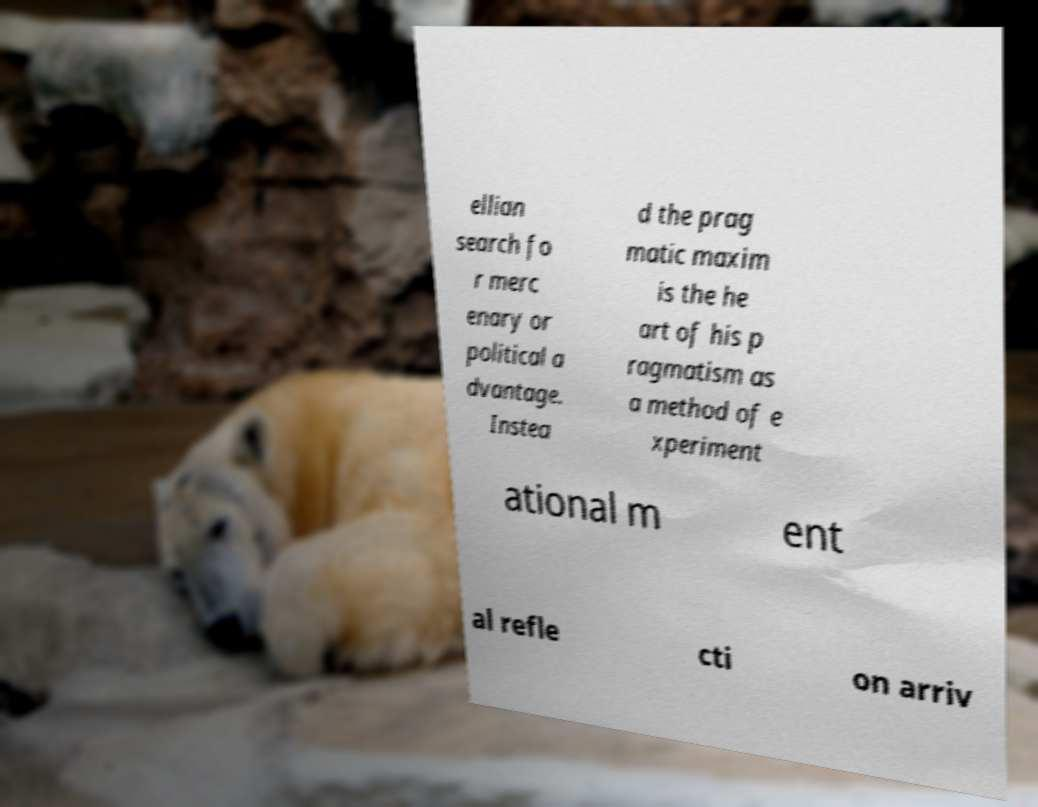Can you read and provide the text displayed in the image?This photo seems to have some interesting text. Can you extract and type it out for me? ellian search fo r merc enary or political a dvantage. Instea d the prag matic maxim is the he art of his p ragmatism as a method of e xperiment ational m ent al refle cti on arriv 